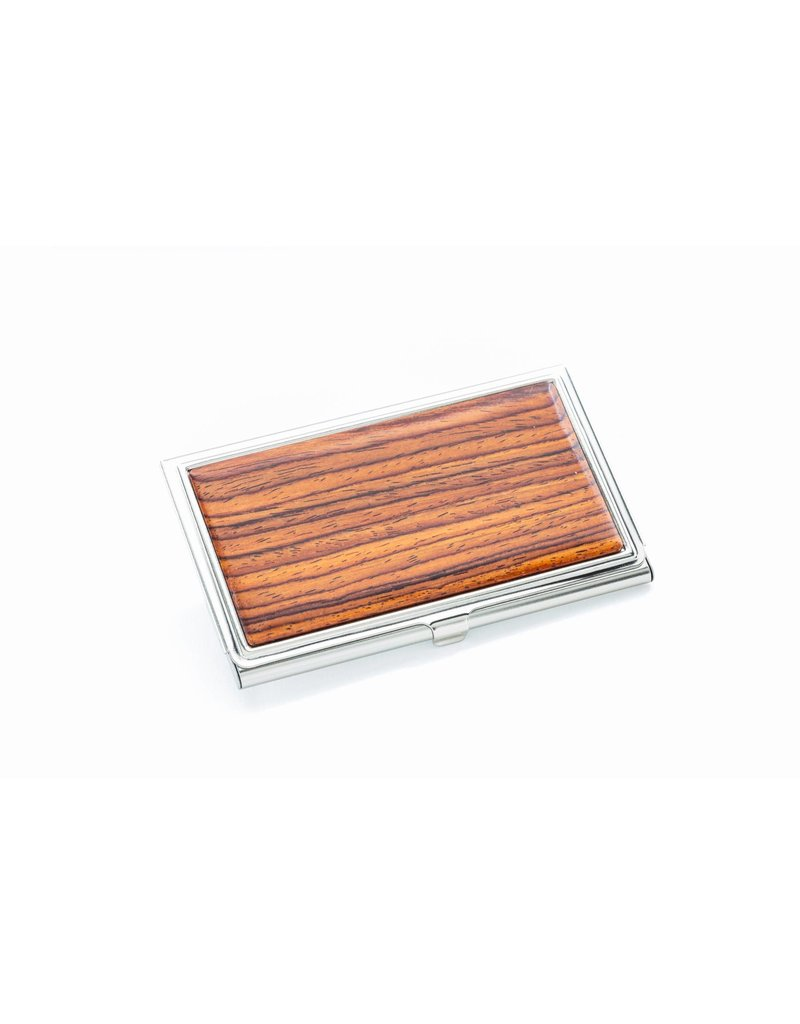What might the intended use for this case be, judging by its design? The design of the case in the image—with its flat, compact shape and the presence of what seems to be a clasp for opening and closing—suggests it could serve as a business card holder. It's slim enough to fit comfortably in a pocket or bag, making it a functional and stylish accessory for professionals who wish to keep their business cards neat and accessible. The combination of the possibly high-quality wood panel and metal finish also implies that it's not merely practical but designed to make a statement, thereby reflecting on the user's personal style and professionalism. 